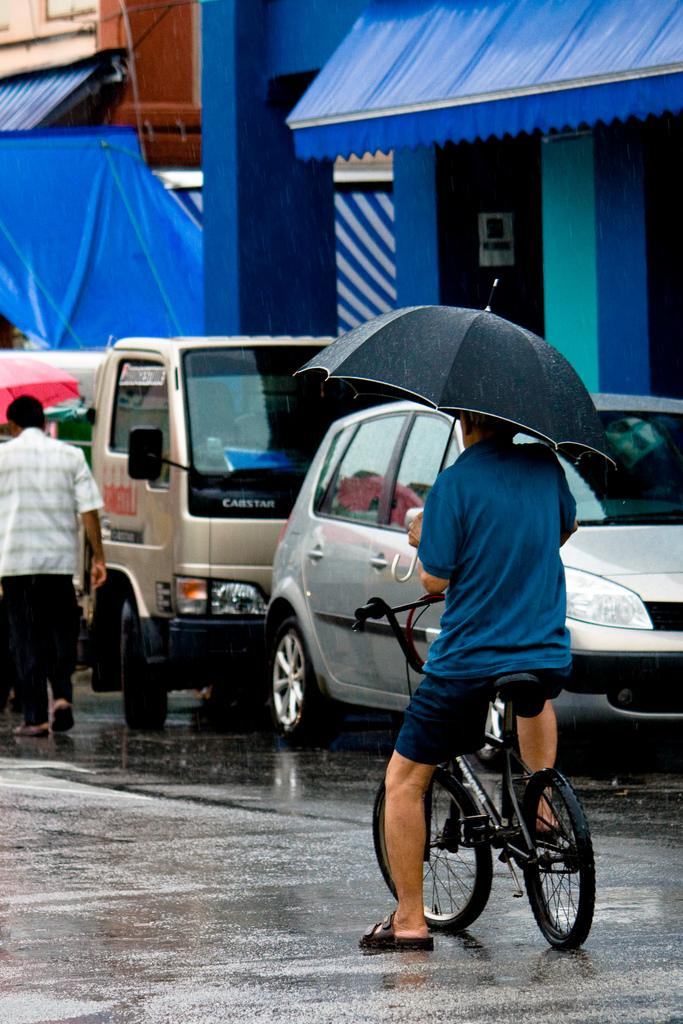Who is the main subject in the image? There is a man in the image. What is the man doing in the image? The man is riding a bicycle. What is the man holding while riding the bicycle? The man is holding an umbrella. What can be seen in the background of the image? There are cars and vehicles, as well as buildings, in the background of the image. What type of produce is the man harvesting in the image? There is no produce present in the image; the man is riding a bicycle and holding an umbrella. What is the man's hope for the future while riding the bicycle? The image does not provide any information about the man's hopes or future plans. 